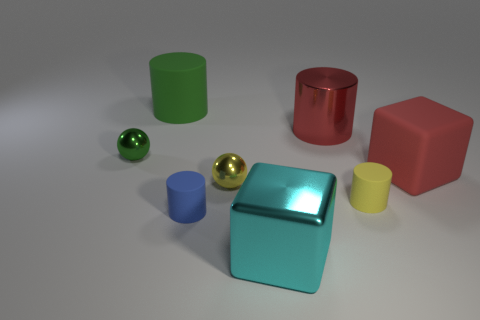What material is the red object that is the same shape as the cyan metal thing?
Your answer should be compact. Rubber. There is a metallic cylinder; is it the same color as the large rubber thing that is in front of the green rubber cylinder?
Provide a succinct answer. Yes. There is a big block that is to the right of the big red cylinder; what material is it?
Ensure brevity in your answer.  Rubber. There is a large thing that is the same color as the big matte cube; what is its shape?
Your answer should be very brief. Cylinder. What size is the green sphere that is the same material as the large cyan block?
Provide a short and direct response. Small. Is the number of small yellow things less than the number of small green metallic objects?
Provide a succinct answer. No. How many big objects are blue things or red rubber spheres?
Give a very brief answer. 0. How many large objects are both on the left side of the yellow rubber cylinder and on the right side of the blue cylinder?
Ensure brevity in your answer.  2. Is the number of big objects greater than the number of large brown cylinders?
Keep it short and to the point. Yes. How many other things are there of the same shape as the small yellow metal object?
Offer a terse response. 1. 